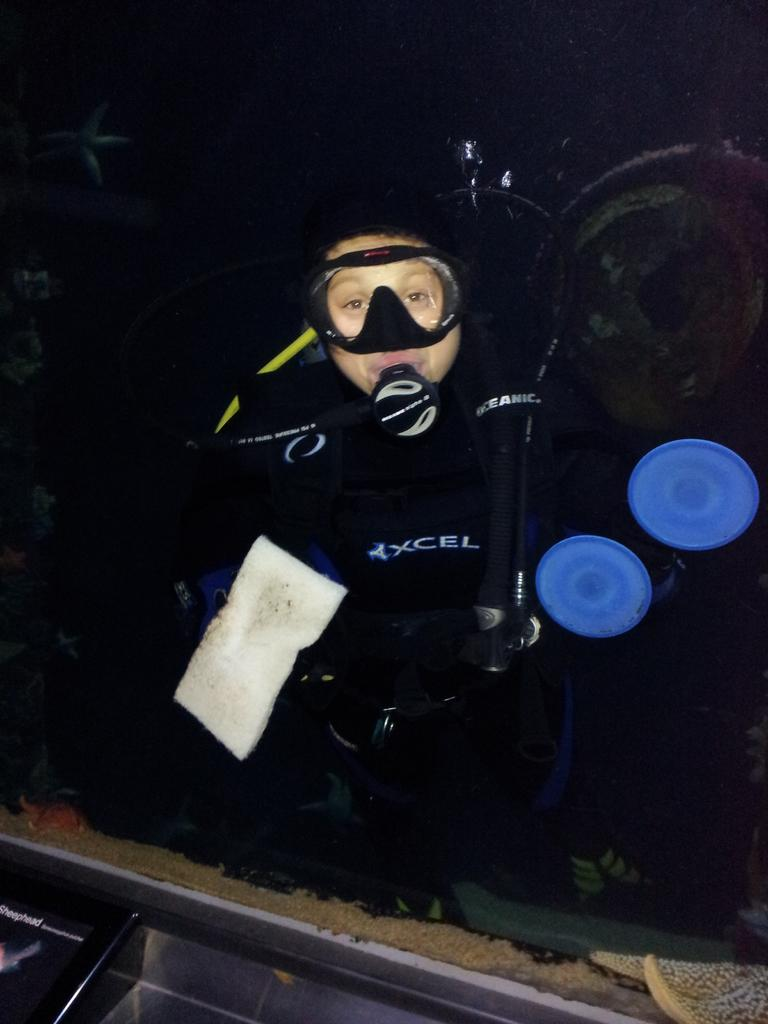Who or what is the main subject of the image? There is a person in the image. What accessory is visible on the person? Swimming goggles are visible in the image. Can you describe any other objects in the image? There are other objects in the image, but their specific details are not mentioned in the provided facts. How would you describe the overall appearance of the image? The background of the image is dark. How many women are depicted in the image? The provided facts do not mention any women in the image; there is only a person mentioned. Is there a cobweb visible in the image? There is no mention of a cobweb in the provided facts, so it cannot be determined from the image. 